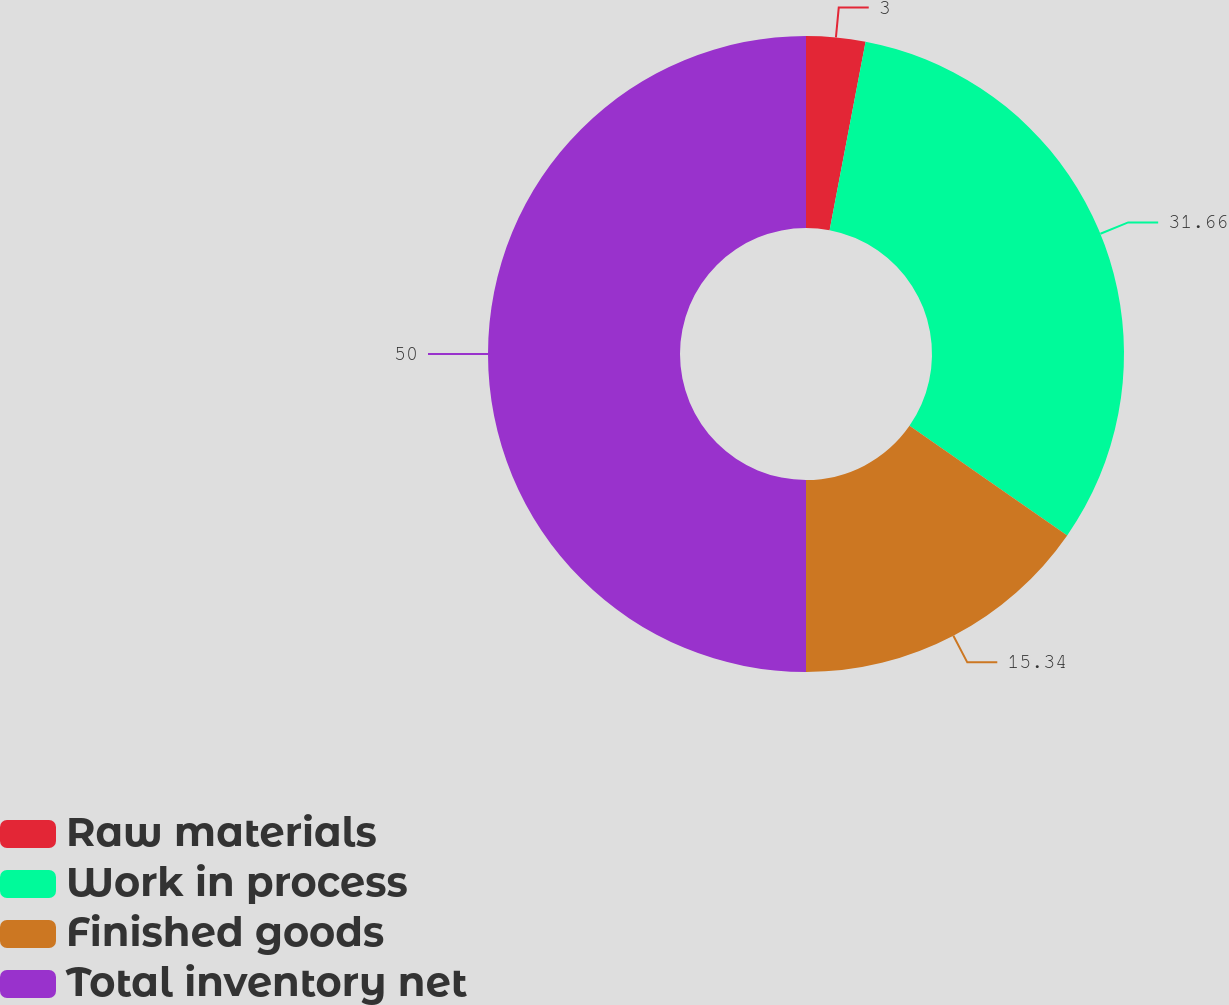Convert chart. <chart><loc_0><loc_0><loc_500><loc_500><pie_chart><fcel>Raw materials<fcel>Work in process<fcel>Finished goods<fcel>Total inventory net<nl><fcel>3.0%<fcel>31.66%<fcel>15.34%<fcel>50.0%<nl></chart> 